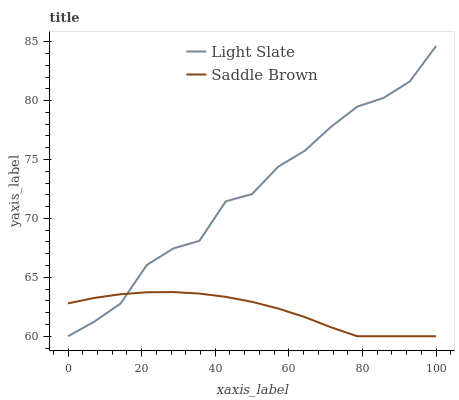Does Saddle Brown have the minimum area under the curve?
Answer yes or no. Yes. Does Light Slate have the maximum area under the curve?
Answer yes or no. Yes. Does Saddle Brown have the maximum area under the curve?
Answer yes or no. No. Is Saddle Brown the smoothest?
Answer yes or no. Yes. Is Light Slate the roughest?
Answer yes or no. Yes. Is Saddle Brown the roughest?
Answer yes or no. No. Does Light Slate have the lowest value?
Answer yes or no. Yes. Does Light Slate have the highest value?
Answer yes or no. Yes. Does Saddle Brown have the highest value?
Answer yes or no. No. Does Saddle Brown intersect Light Slate?
Answer yes or no. Yes. Is Saddle Brown less than Light Slate?
Answer yes or no. No. Is Saddle Brown greater than Light Slate?
Answer yes or no. No. 